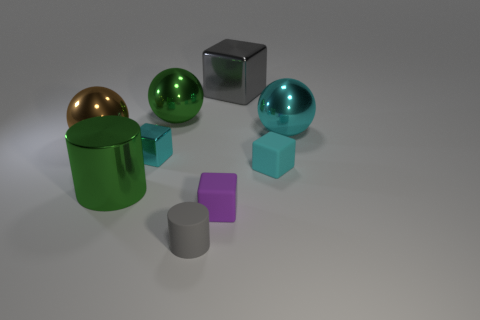Subtract all small shiny cubes. How many cubes are left? 3 Subtract all cyan cylinders. How many cyan blocks are left? 2 Add 1 small green shiny objects. How many objects exist? 10 Subtract all gray cubes. How many cubes are left? 3 Subtract 2 cubes. How many cubes are left? 2 Subtract all cylinders. How many objects are left? 7 Subtract all green cylinders. Subtract all red blocks. How many cylinders are left? 1 Add 2 metallic things. How many metallic things exist? 8 Subtract 1 cyan spheres. How many objects are left? 8 Subtract all tiny cyan metal cubes. Subtract all metallic spheres. How many objects are left? 5 